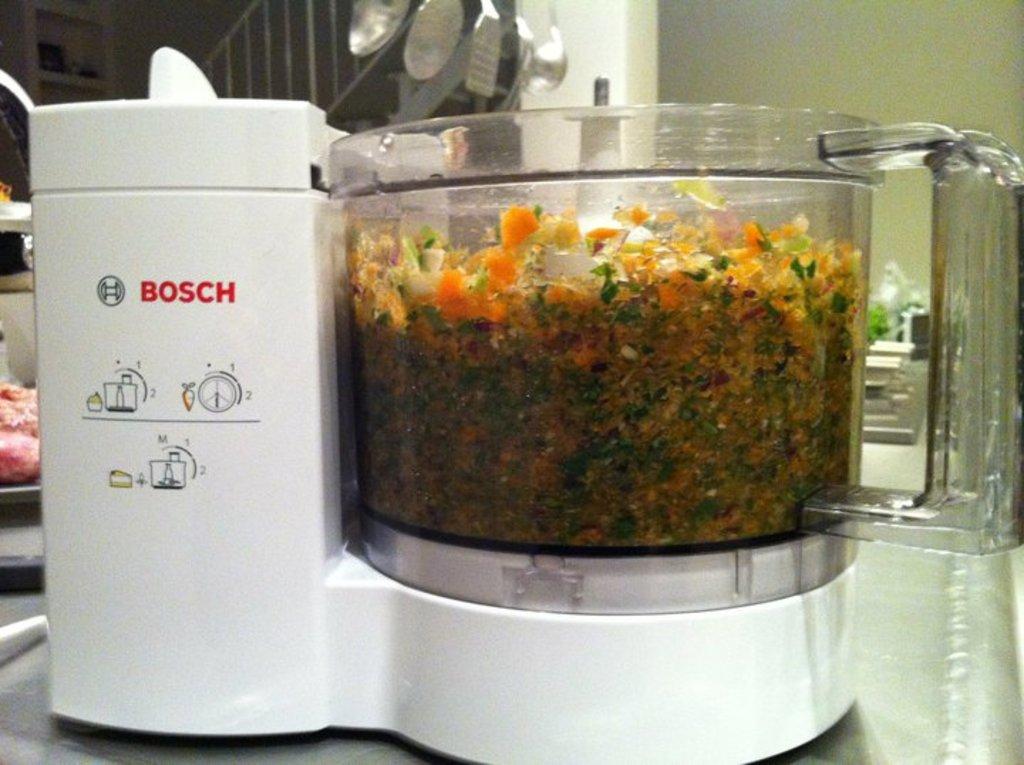What company made this blender?
Ensure brevity in your answer.  Bosch. What is the second to last letter in the brand name of this product?
Your answer should be very brief. C. 